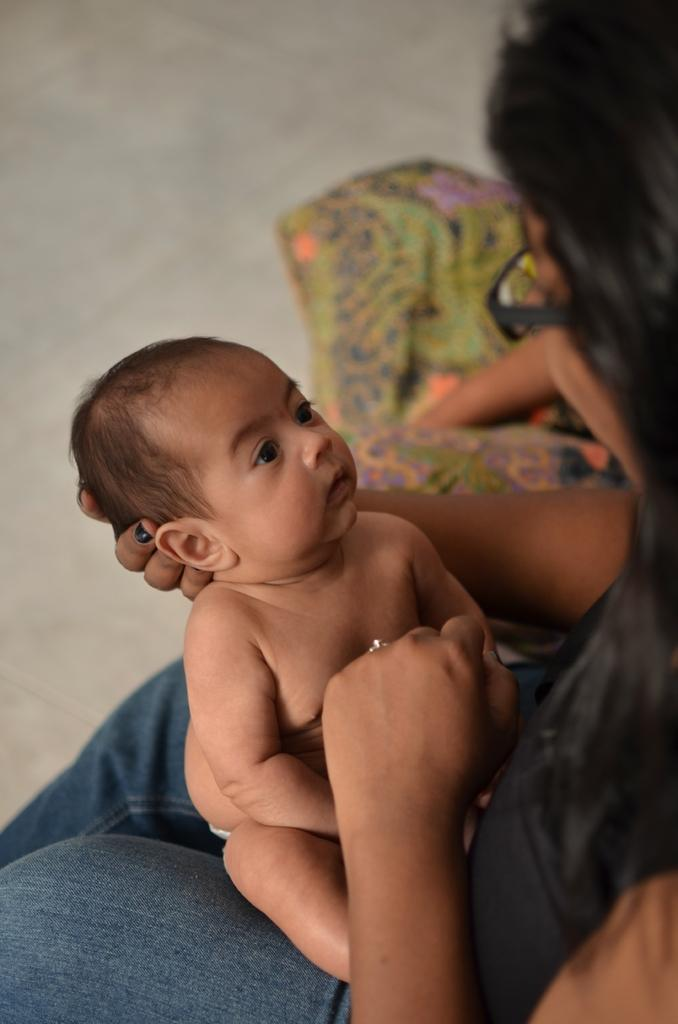What is the woman in the image doing? The woman is sitting in the image and holding a baby. Can you describe the other person in the image? There is another person sitting in the image. What is the surface beneath the people in the image? The bottom of the image contains a floor. What type of grass is growing on the stick held by the woman in the image? There is no grass or stick present in the image. What prose is being recited by the person sitting in the image? There is no indication of any prose being recited in the image. 